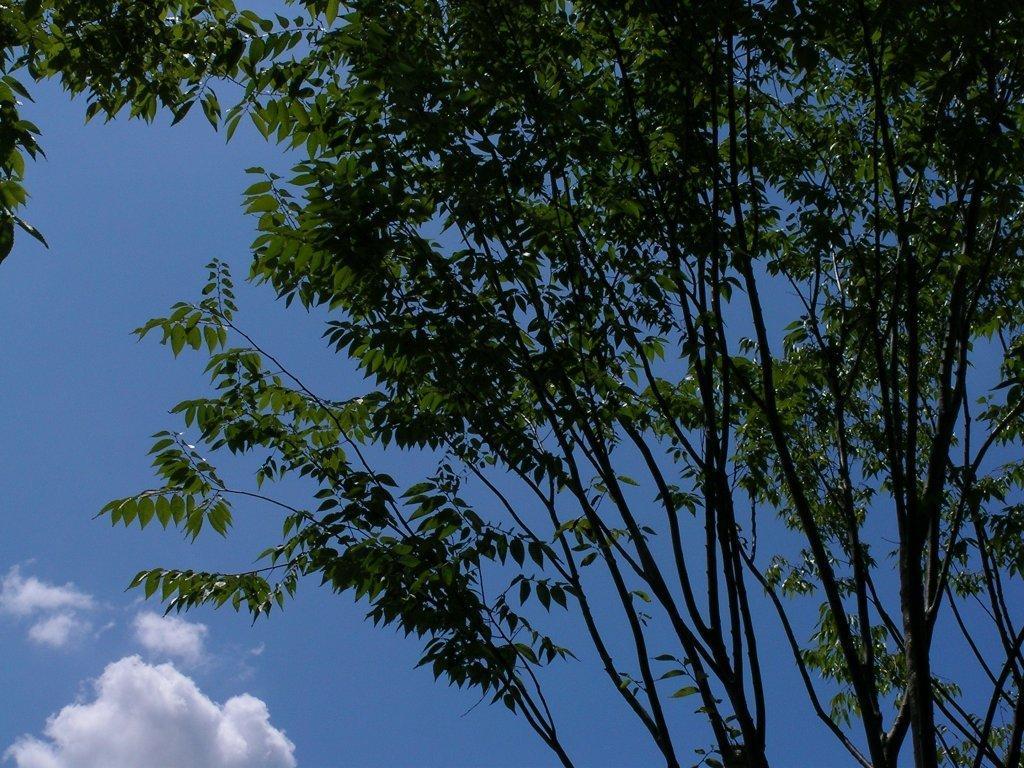How would you summarize this image in a sentence or two? In this image we can see some branches of a tree. On the backside we can see the sky which looks cloudy. 